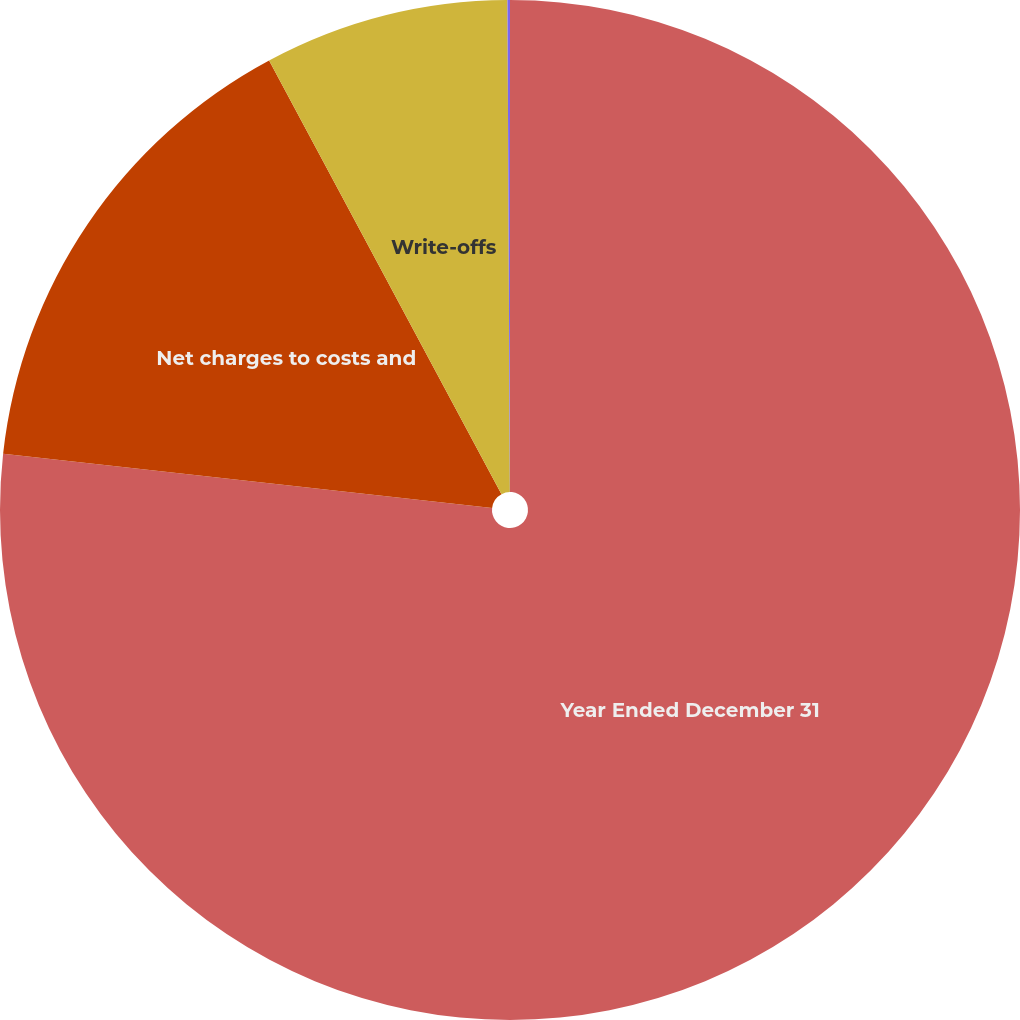<chart> <loc_0><loc_0><loc_500><loc_500><pie_chart><fcel>Year Ended December 31<fcel>Net charges to costs and<fcel>Write-offs<fcel>Other 1<nl><fcel>76.76%<fcel>15.41%<fcel>7.75%<fcel>0.08%<nl></chart> 